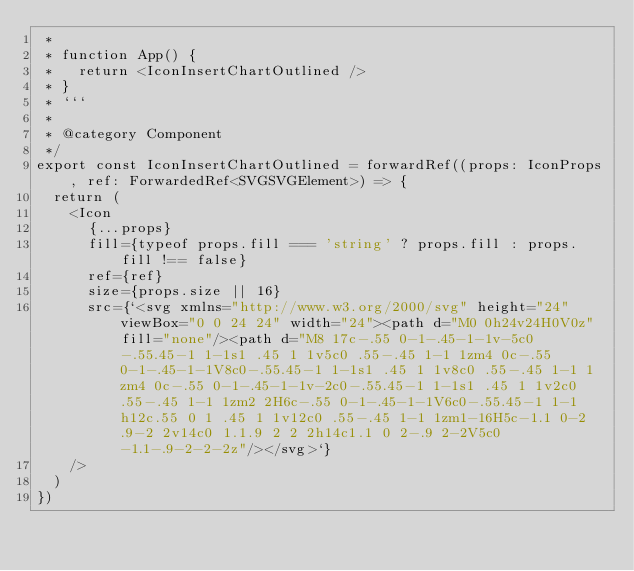Convert code to text. <code><loc_0><loc_0><loc_500><loc_500><_TypeScript_> *
 * function App() {
 *   return <IconInsertChartOutlined />
 * }
 * ```
 *
 * @category Component
 */
export const IconInsertChartOutlined = forwardRef((props: IconProps, ref: ForwardedRef<SVGSVGElement>) => {
  return (
    <Icon
      {...props}
      fill={typeof props.fill === 'string' ? props.fill : props.fill !== false}
      ref={ref}
      size={props.size || 16}
      src={`<svg xmlns="http://www.w3.org/2000/svg" height="24" viewBox="0 0 24 24" width="24"><path d="M0 0h24v24H0V0z" fill="none"/><path d="M8 17c-.55 0-1-.45-1-1v-5c0-.55.45-1 1-1s1 .45 1 1v5c0 .55-.45 1-1 1zm4 0c-.55 0-1-.45-1-1V8c0-.55.45-1 1-1s1 .45 1 1v8c0 .55-.45 1-1 1zm4 0c-.55 0-1-.45-1-1v-2c0-.55.45-1 1-1s1 .45 1 1v2c0 .55-.45 1-1 1zm2 2H6c-.55 0-1-.45-1-1V6c0-.55.45-1 1-1h12c.55 0 1 .45 1 1v12c0 .55-.45 1-1 1zm1-16H5c-1.1 0-2 .9-2 2v14c0 1.1.9 2 2 2h14c1.1 0 2-.9 2-2V5c0-1.1-.9-2-2-2z"/></svg>`}
    />
  )
})
</code> 